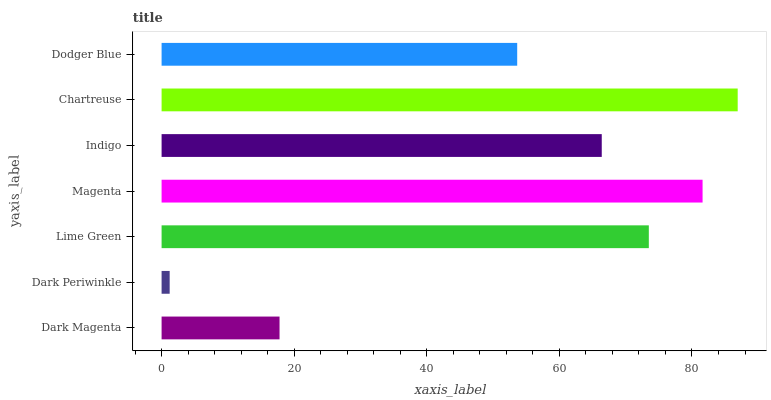Is Dark Periwinkle the minimum?
Answer yes or no. Yes. Is Chartreuse the maximum?
Answer yes or no. Yes. Is Lime Green the minimum?
Answer yes or no. No. Is Lime Green the maximum?
Answer yes or no. No. Is Lime Green greater than Dark Periwinkle?
Answer yes or no. Yes. Is Dark Periwinkle less than Lime Green?
Answer yes or no. Yes. Is Dark Periwinkle greater than Lime Green?
Answer yes or no. No. Is Lime Green less than Dark Periwinkle?
Answer yes or no. No. Is Indigo the high median?
Answer yes or no. Yes. Is Indigo the low median?
Answer yes or no. Yes. Is Chartreuse the high median?
Answer yes or no. No. Is Dark Periwinkle the low median?
Answer yes or no. No. 